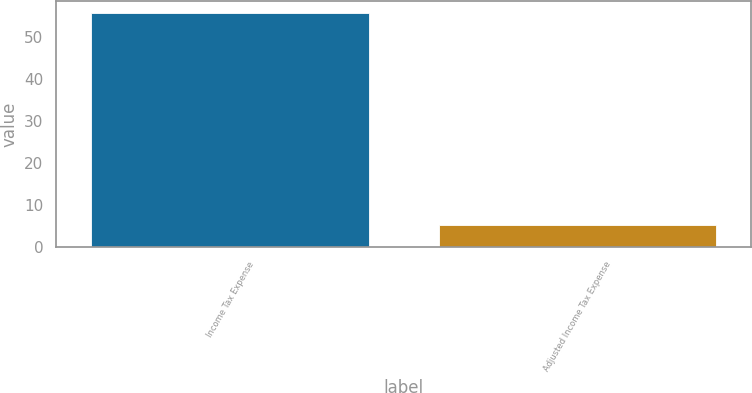Convert chart. <chart><loc_0><loc_0><loc_500><loc_500><bar_chart><fcel>Income Tax Expense<fcel>Adjusted Income Tax Expense<nl><fcel>55.6<fcel>5.2<nl></chart> 